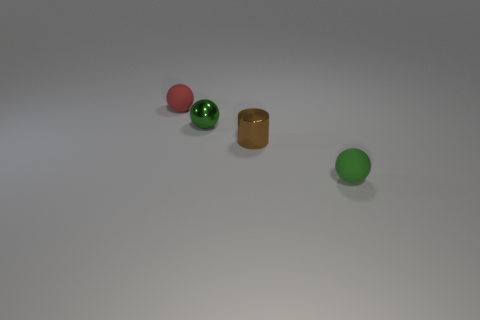Add 4 small metallic balls. How many objects exist? 8 Subtract all spheres. How many objects are left? 1 Subtract all small green blocks. Subtract all green shiny spheres. How many objects are left? 3 Add 1 tiny green shiny things. How many tiny green shiny things are left? 2 Add 3 small brown objects. How many small brown objects exist? 4 Subtract 0 gray balls. How many objects are left? 4 